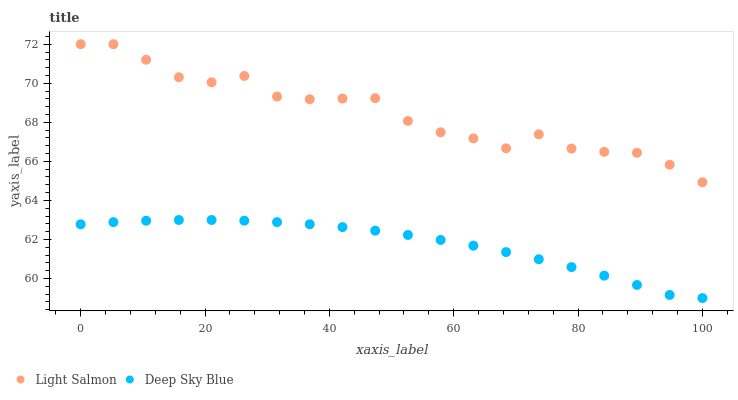Does Deep Sky Blue have the minimum area under the curve?
Answer yes or no. Yes. Does Light Salmon have the maximum area under the curve?
Answer yes or no. Yes. Does Deep Sky Blue have the maximum area under the curve?
Answer yes or no. No. Is Deep Sky Blue the smoothest?
Answer yes or no. Yes. Is Light Salmon the roughest?
Answer yes or no. Yes. Is Deep Sky Blue the roughest?
Answer yes or no. No. Does Deep Sky Blue have the lowest value?
Answer yes or no. Yes. Does Light Salmon have the highest value?
Answer yes or no. Yes. Does Deep Sky Blue have the highest value?
Answer yes or no. No. Is Deep Sky Blue less than Light Salmon?
Answer yes or no. Yes. Is Light Salmon greater than Deep Sky Blue?
Answer yes or no. Yes. Does Deep Sky Blue intersect Light Salmon?
Answer yes or no. No. 